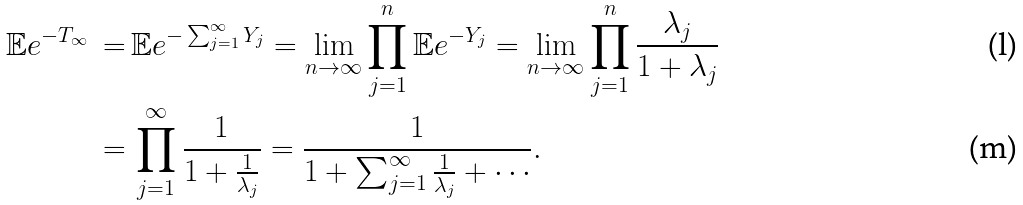Convert formula to latex. <formula><loc_0><loc_0><loc_500><loc_500>\mathbb { E } e ^ { - T _ { \infty } } \, = \, & \mathbb { E } e ^ { - \sum _ { j = 1 } ^ { \infty } Y _ { j } } = \lim _ { n \to \infty } \prod _ { j = 1 } ^ { n } \mathbb { E } e ^ { - Y _ { j } } = \lim _ { n \to \infty } \prod _ { j = 1 } ^ { n } \frac { \lambda _ { j } } { 1 + \lambda _ { j } } \\ = \, & \prod _ { j = 1 } ^ { \infty } \frac { 1 } { 1 + \frac { 1 } { \lambda _ { j } } } = \frac { 1 } { 1 + \sum _ { j = 1 } ^ { \infty } \frac { 1 } { \lambda _ { j } } + \cdots } .</formula> 